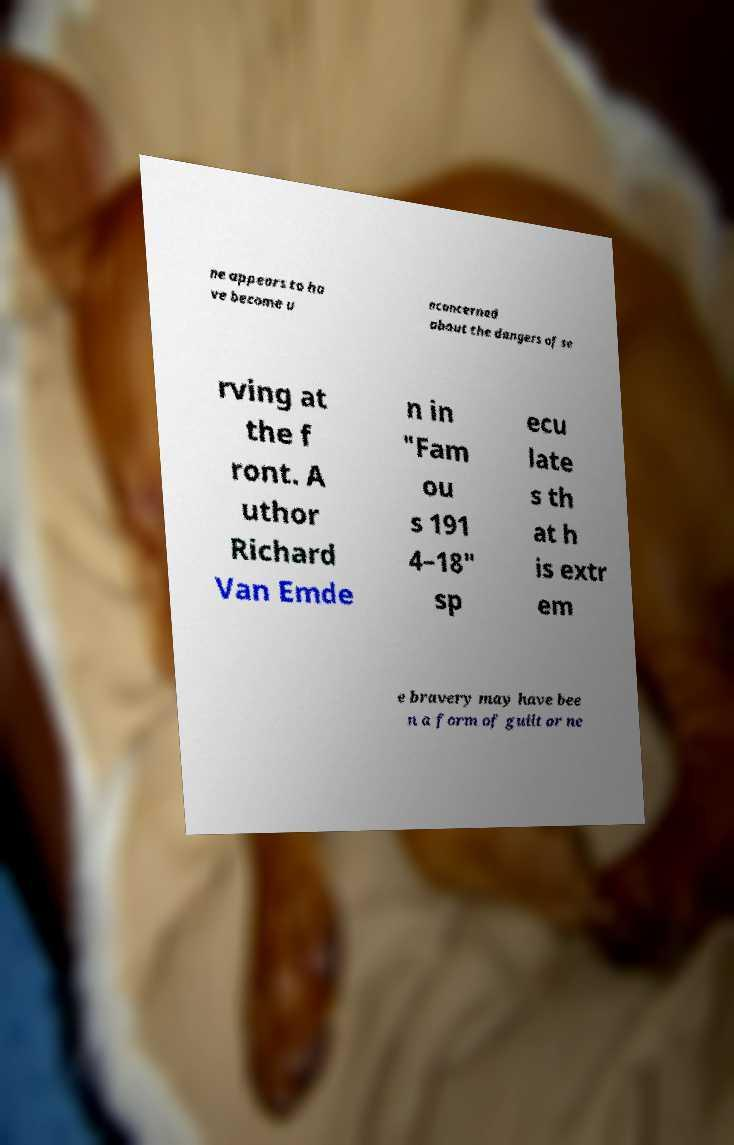I need the written content from this picture converted into text. Can you do that? ne appears to ha ve become u nconcerned about the dangers of se rving at the f ront. A uthor Richard Van Emde n in "Fam ou s 191 4–18" sp ecu late s th at h is extr em e bravery may have bee n a form of guilt or ne 